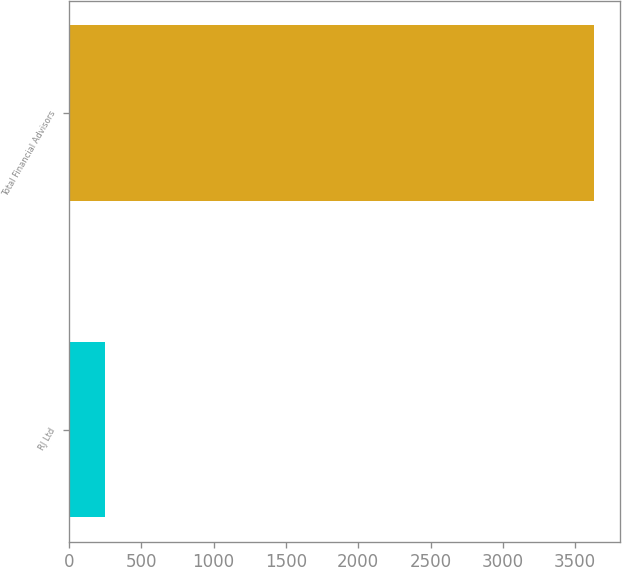Convert chart to OTSL. <chart><loc_0><loc_0><loc_500><loc_500><bar_chart><fcel>RJ Ltd<fcel>Total Financial Advisors<nl><fcel>246<fcel>3628<nl></chart> 